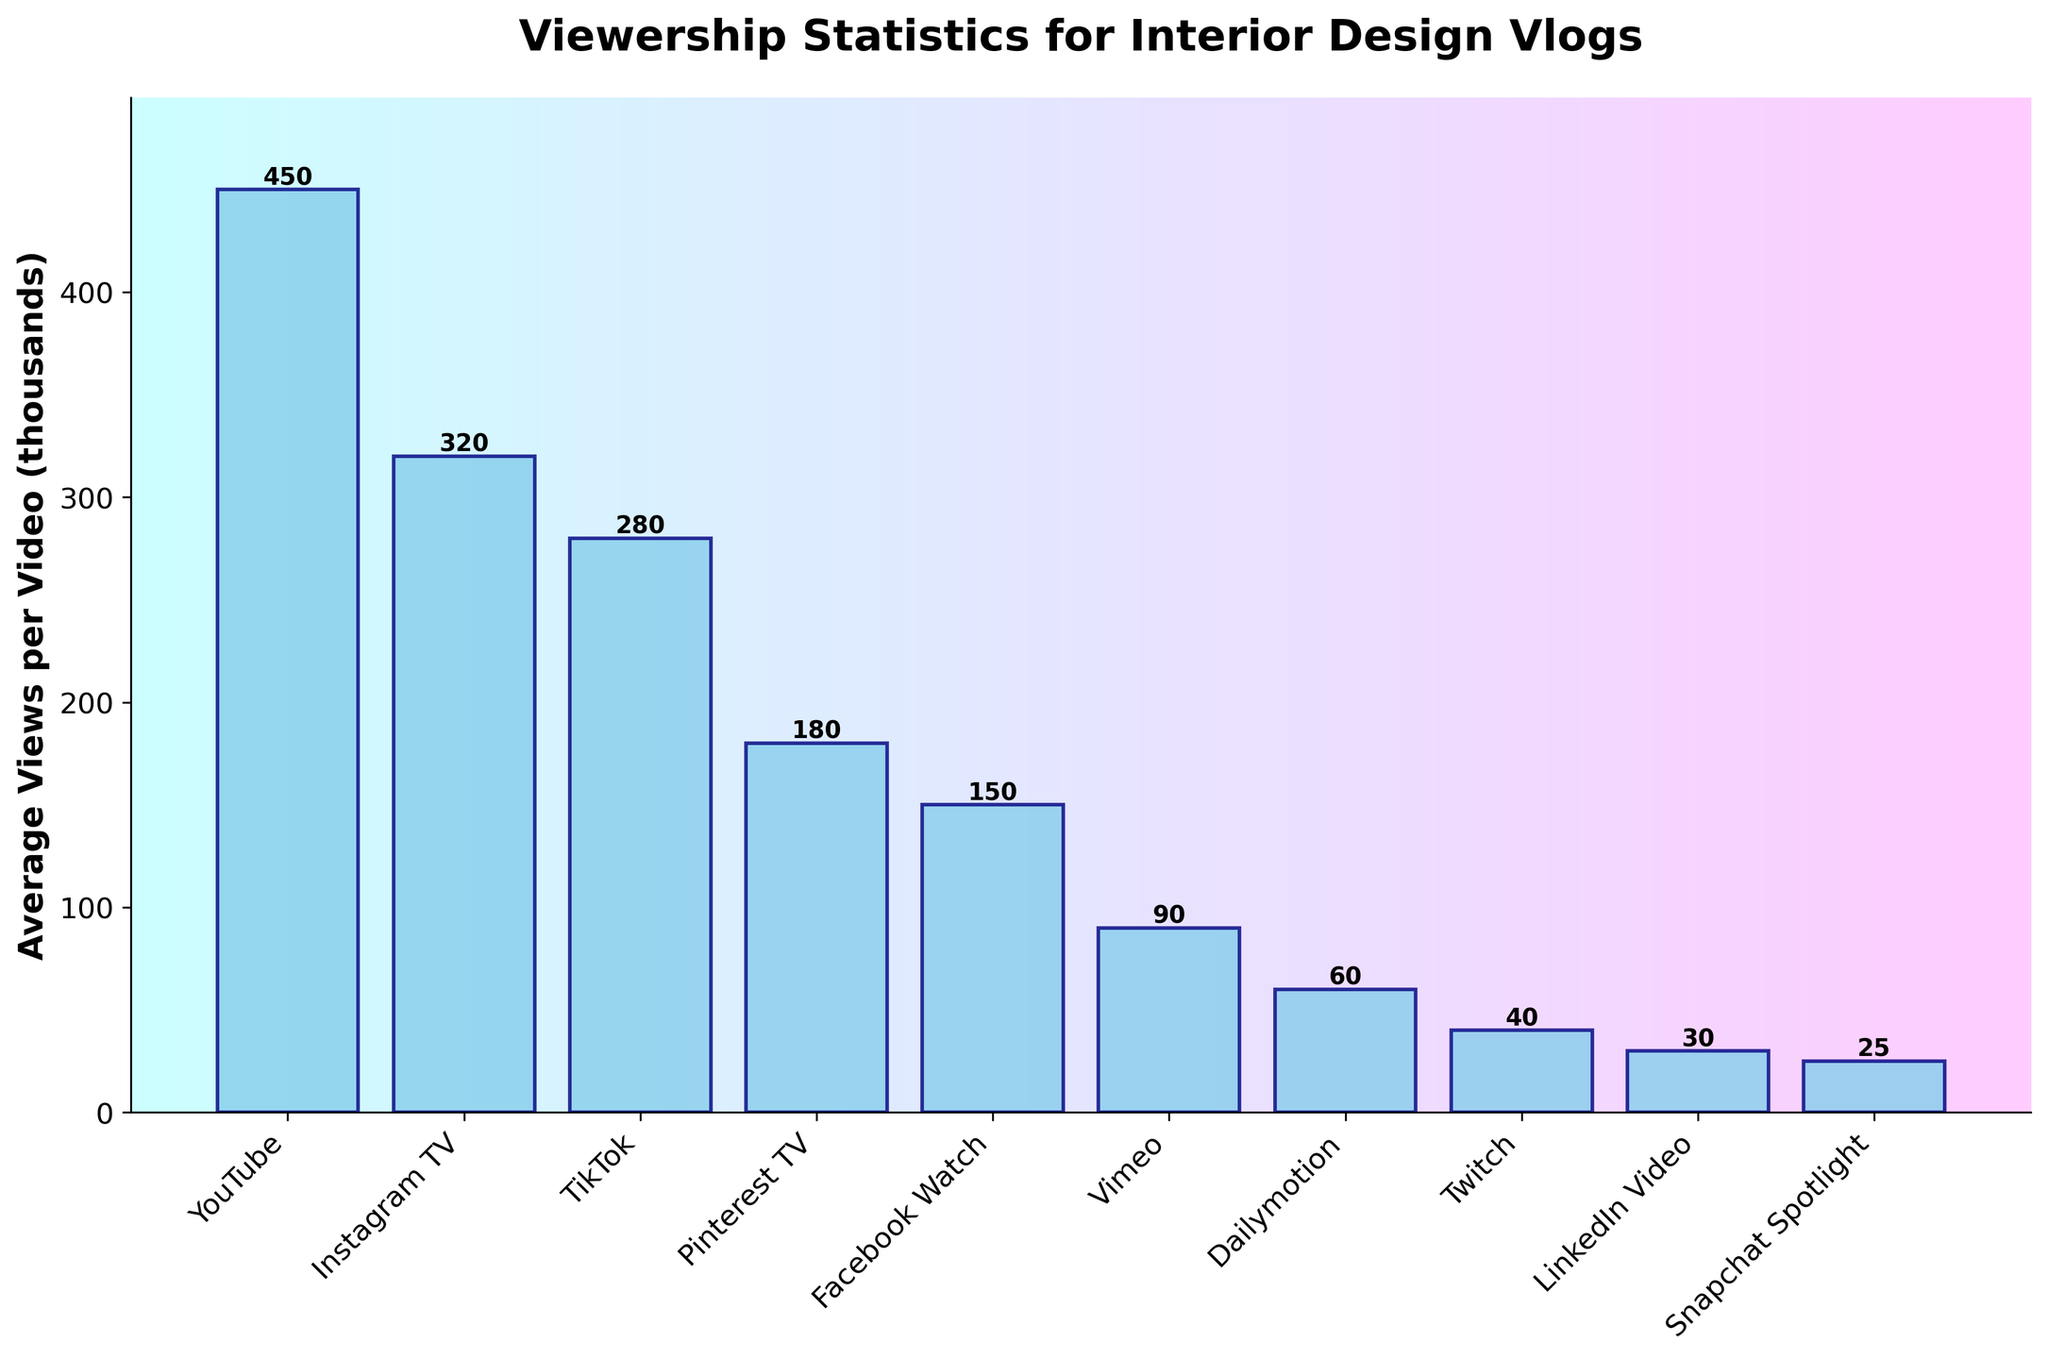How many more average views per video does YouTube have compared to Instagram TV? To find the difference in average views per video between YouTube and Instagram TV, subtract the average views of Instagram TV (320,000) from YouTube's average views (450,000). 450,000 - 320,000 = 130,000
Answer: 130,000 Which platform has the fewest average views per video? By looking at the heights of the bars, the shortest bar represents the platform with the fewest average views. The shortest bar represents Snapchat Spotlight with 25,000 views.
Answer: Snapchat Spotlight What is the sum of average views per video for Instagram TV, Pinterest TV, and Facebook Watch? Add the average views for Instagram TV (320,000), Pinterest TV (180,000), and Facebook Watch (150,000). 320,000 + 180,000 + 150,000 = 650,000
Answer: 650,000 Which platforms have average views per video greater than 200,000? By comparing the heights of the bars that are taller than the 200,000 mark, YouTube, Instagram TV, and TikTok have average views per video greater than 200,000.
Answer: YouTube, Instagram TV, TikTok What is the ratio of average views per video on YouTube to Vimeo? Divide YouTube's average views (450,000) by Vimeo's average views (90,000). 450,000 / 90,000 = 5
Answer: 5 Is the average viewership of TikTok closer to that of Instagram TV or Pinterest TV? Calculate the absolute differences: TikTok to Instagram TV (320,000 - 280,000 = 40,000) and TikTok to Pinterest TV (280,000 - 180,000 = 100,000). The smaller difference is 40,000, so TikTok's average viewership is closer to Instagram TV.
Answer: Instagram TV What is the total average viewership for all platforms combined? Sum all the average views per video for each platform: 450,000 + 320,000 + 280,000 + 180,000 + 150,000 + 90,000 + 60,000 + 40,000 + 30,000 + 25,000 = 1,625,000
Answer: 1,625,000 Which platform's average views per video is exactly half of another platform's average views per video? By comparing the bars and noting that Vimeo (90,000) is half of YouTube (450,000 / 2 = 225,000), no platform exactly matches. But LinkedIn Video (30,000) is half of Pinterest TV (180,000 / 6 = 30,000).
Answer: LinkedIn Video (to Pinterest TV) How many platforms have fewer than 100,000 average views per video? Count the bars with heights less than the 100,000 mark. Vimeo, Dailymotion, Twitch, LinkedIn Video, and Snapchat Spotlight. There are 5 platforms.
Answer: 5 What percentage of the total amount is represented by Facebook Watch's average views? Divide Facebook Watch's average views (150,000) by the total viewership (1,625,000) and multiply by 100. (150,000 / 1,625,000) * 100 ≈ 9.23%
Answer: 9.23% 